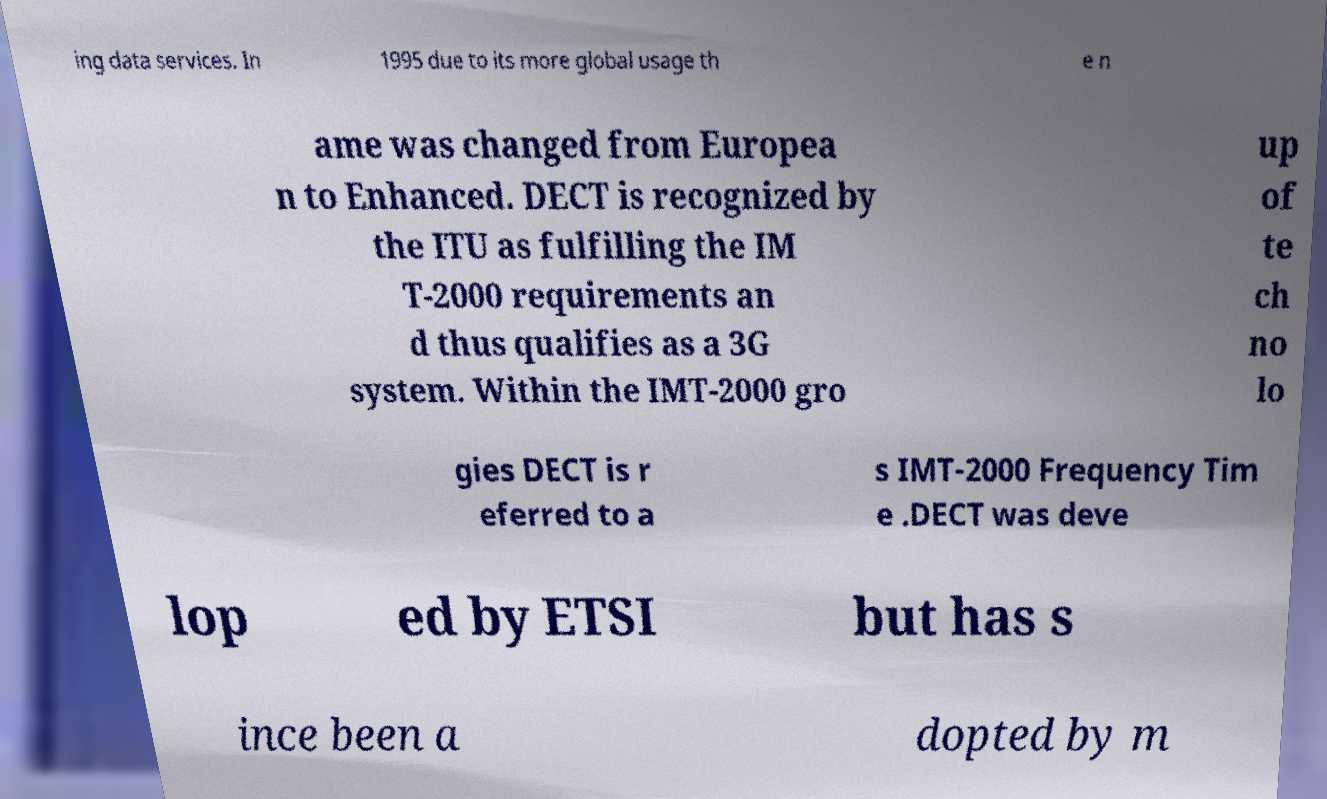Please read and relay the text visible in this image. What does it say? ing data services. In 1995 due to its more global usage th e n ame was changed from Europea n to Enhanced. DECT is recognized by the ITU as fulfilling the IM T-2000 requirements an d thus qualifies as a 3G system. Within the IMT-2000 gro up of te ch no lo gies DECT is r eferred to a s IMT-2000 Frequency Tim e .DECT was deve lop ed by ETSI but has s ince been a dopted by m 